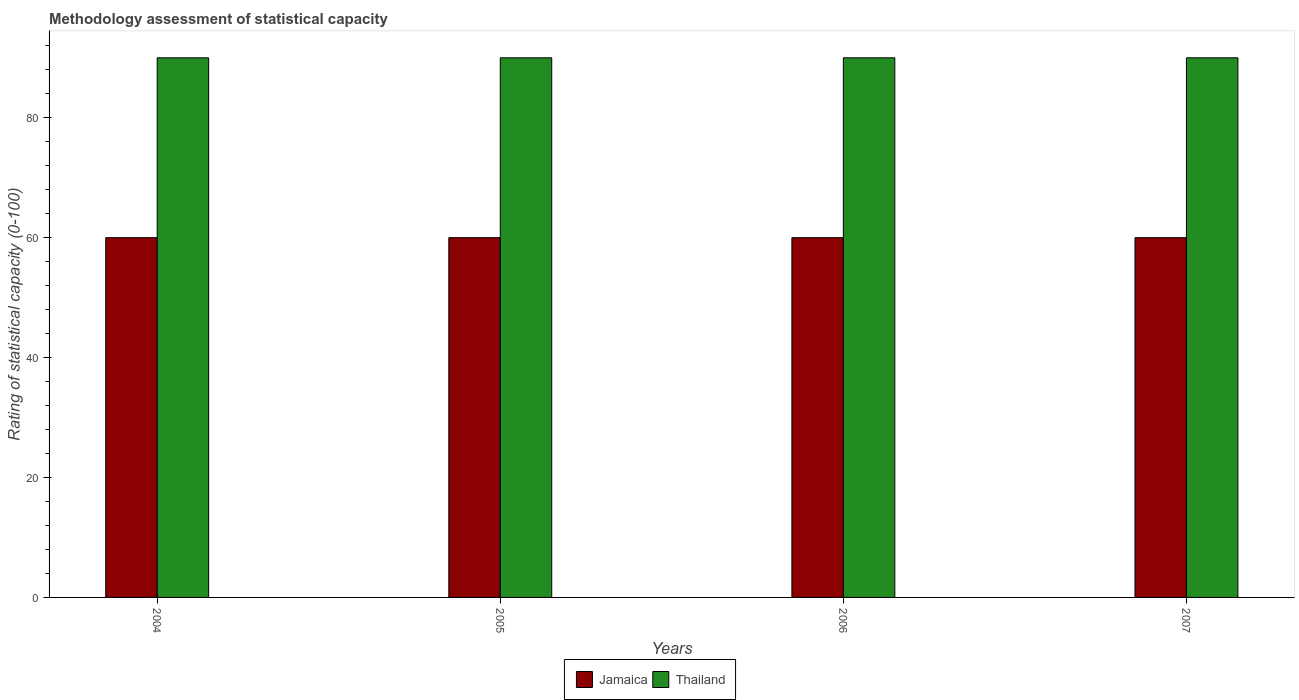How many different coloured bars are there?
Give a very brief answer. 2. How many bars are there on the 3rd tick from the left?
Keep it short and to the point. 2. How many bars are there on the 3rd tick from the right?
Ensure brevity in your answer.  2. What is the label of the 4th group of bars from the left?
Keep it short and to the point. 2007. What is the rating of statistical capacity in Thailand in 2007?
Keep it short and to the point. 90. Across all years, what is the maximum rating of statistical capacity in Jamaica?
Keep it short and to the point. 60. Across all years, what is the minimum rating of statistical capacity in Thailand?
Give a very brief answer. 90. In which year was the rating of statistical capacity in Jamaica maximum?
Ensure brevity in your answer.  2004. What is the total rating of statistical capacity in Thailand in the graph?
Make the answer very short. 360. What is the difference between the rating of statistical capacity in Thailand in 2004 and that in 2005?
Ensure brevity in your answer.  0. What is the difference between the rating of statistical capacity in Jamaica in 2005 and the rating of statistical capacity in Thailand in 2004?
Your answer should be very brief. -30. What is the average rating of statistical capacity in Thailand per year?
Your answer should be compact. 90. In the year 2005, what is the difference between the rating of statistical capacity in Jamaica and rating of statistical capacity in Thailand?
Keep it short and to the point. -30. In how many years, is the rating of statistical capacity in Jamaica greater than 80?
Offer a terse response. 0. Is the sum of the rating of statistical capacity in Thailand in 2005 and 2006 greater than the maximum rating of statistical capacity in Jamaica across all years?
Make the answer very short. Yes. What does the 2nd bar from the left in 2004 represents?
Your response must be concise. Thailand. What does the 2nd bar from the right in 2006 represents?
Your answer should be very brief. Jamaica. How many bars are there?
Your response must be concise. 8. Are the values on the major ticks of Y-axis written in scientific E-notation?
Your answer should be compact. No. Does the graph contain grids?
Make the answer very short. No. Where does the legend appear in the graph?
Provide a short and direct response. Bottom center. How are the legend labels stacked?
Provide a succinct answer. Horizontal. What is the title of the graph?
Make the answer very short. Methodology assessment of statistical capacity. What is the label or title of the X-axis?
Give a very brief answer. Years. What is the label or title of the Y-axis?
Offer a very short reply. Rating of statistical capacity (0-100). What is the Rating of statistical capacity (0-100) of Jamaica in 2004?
Your response must be concise. 60. What is the Rating of statistical capacity (0-100) of Thailand in 2004?
Your answer should be very brief. 90. What is the Rating of statistical capacity (0-100) of Jamaica in 2005?
Keep it short and to the point. 60. What is the Rating of statistical capacity (0-100) of Thailand in 2005?
Keep it short and to the point. 90. What is the Rating of statistical capacity (0-100) in Thailand in 2006?
Provide a short and direct response. 90. What is the Rating of statistical capacity (0-100) of Thailand in 2007?
Provide a succinct answer. 90. Across all years, what is the maximum Rating of statistical capacity (0-100) of Thailand?
Provide a succinct answer. 90. Across all years, what is the minimum Rating of statistical capacity (0-100) of Jamaica?
Provide a succinct answer. 60. What is the total Rating of statistical capacity (0-100) in Jamaica in the graph?
Your response must be concise. 240. What is the total Rating of statistical capacity (0-100) of Thailand in the graph?
Your answer should be compact. 360. What is the difference between the Rating of statistical capacity (0-100) in Jamaica in 2004 and that in 2005?
Ensure brevity in your answer.  0. What is the difference between the Rating of statistical capacity (0-100) of Thailand in 2004 and that in 2005?
Your answer should be very brief. 0. What is the difference between the Rating of statistical capacity (0-100) of Jamaica in 2004 and that in 2007?
Offer a very short reply. 0. What is the difference between the Rating of statistical capacity (0-100) of Jamaica in 2005 and that in 2006?
Your answer should be compact. 0. What is the difference between the Rating of statistical capacity (0-100) in Thailand in 2005 and that in 2006?
Provide a short and direct response. 0. What is the difference between the Rating of statistical capacity (0-100) of Jamaica in 2006 and that in 2007?
Provide a short and direct response. 0. What is the difference between the Rating of statistical capacity (0-100) in Jamaica in 2004 and the Rating of statistical capacity (0-100) in Thailand in 2006?
Provide a succinct answer. -30. What is the difference between the Rating of statistical capacity (0-100) in Jamaica in 2005 and the Rating of statistical capacity (0-100) in Thailand in 2007?
Provide a short and direct response. -30. What is the difference between the Rating of statistical capacity (0-100) in Jamaica in 2006 and the Rating of statistical capacity (0-100) in Thailand in 2007?
Make the answer very short. -30. In the year 2005, what is the difference between the Rating of statistical capacity (0-100) in Jamaica and Rating of statistical capacity (0-100) in Thailand?
Make the answer very short. -30. In the year 2006, what is the difference between the Rating of statistical capacity (0-100) of Jamaica and Rating of statistical capacity (0-100) of Thailand?
Provide a short and direct response. -30. What is the ratio of the Rating of statistical capacity (0-100) of Thailand in 2004 to that in 2006?
Give a very brief answer. 1. What is the ratio of the Rating of statistical capacity (0-100) in Jamaica in 2004 to that in 2007?
Provide a short and direct response. 1. What is the ratio of the Rating of statistical capacity (0-100) of Jamaica in 2005 to that in 2006?
Provide a short and direct response. 1. What is the ratio of the Rating of statistical capacity (0-100) in Jamaica in 2005 to that in 2007?
Your answer should be compact. 1. What is the ratio of the Rating of statistical capacity (0-100) in Thailand in 2005 to that in 2007?
Offer a very short reply. 1. What is the ratio of the Rating of statistical capacity (0-100) of Thailand in 2006 to that in 2007?
Your answer should be very brief. 1. What is the difference between the highest and the second highest Rating of statistical capacity (0-100) in Jamaica?
Keep it short and to the point. 0. What is the difference between the highest and the second highest Rating of statistical capacity (0-100) of Thailand?
Give a very brief answer. 0. What is the difference between the highest and the lowest Rating of statistical capacity (0-100) of Jamaica?
Provide a succinct answer. 0. What is the difference between the highest and the lowest Rating of statistical capacity (0-100) of Thailand?
Your answer should be very brief. 0. 